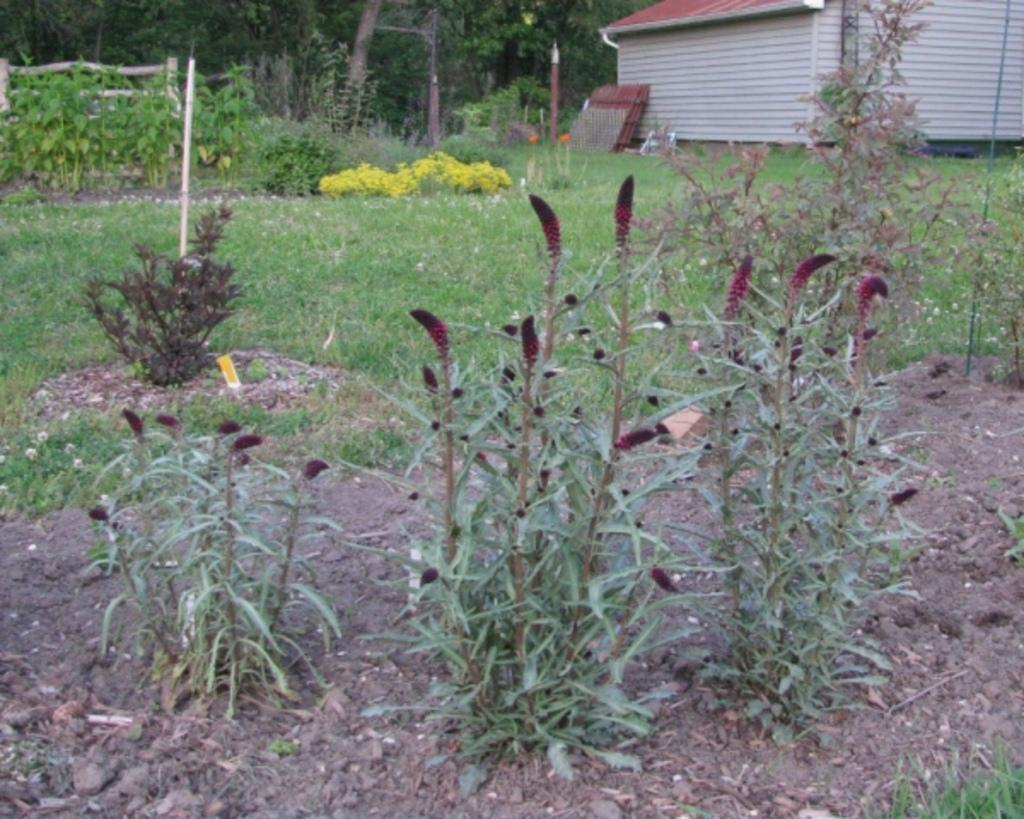What is located in the foreground of the image? There are flowers in the foreground of the image. What are the flowers associated with? The flowers are associated with plants. What can be seen in the background of the image? There are plants, grass, trees, objects, and a shelter in the background of the image. What type of pets can be seen playing with a notebook in the image? There are no pets or notebooks present in the image. What is the beam used for in the image? There is no beam present in the image. 